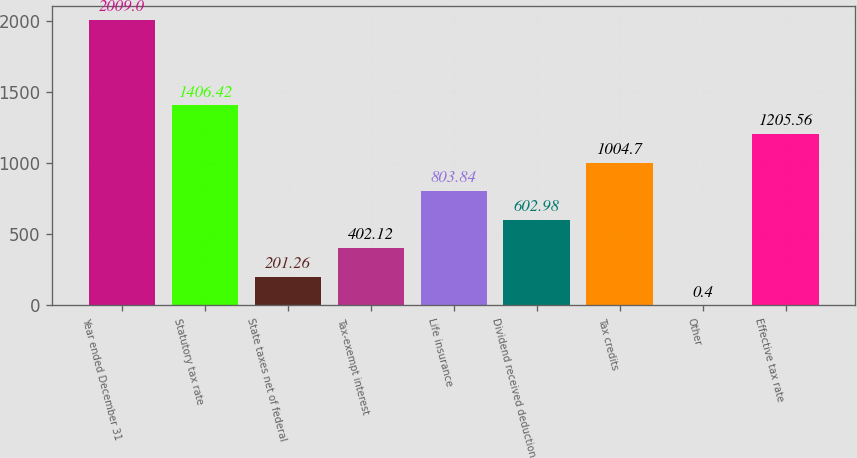<chart> <loc_0><loc_0><loc_500><loc_500><bar_chart><fcel>Year ended December 31<fcel>Statutory tax rate<fcel>State taxes net of federal<fcel>Tax-exempt interest<fcel>Life insurance<fcel>Dividend received deduction<fcel>Tax credits<fcel>Other<fcel>Effective tax rate<nl><fcel>2009<fcel>1406.42<fcel>201.26<fcel>402.12<fcel>803.84<fcel>602.98<fcel>1004.7<fcel>0.4<fcel>1205.56<nl></chart> 